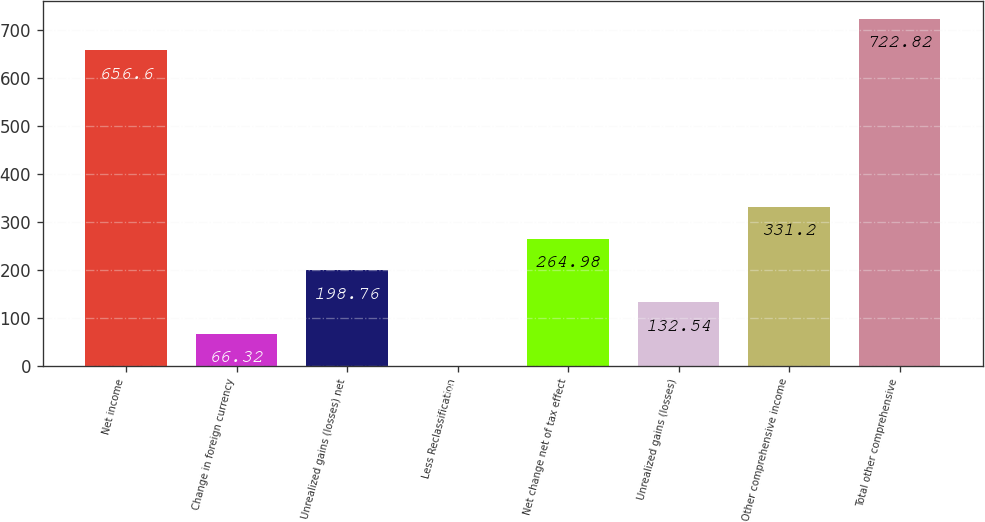<chart> <loc_0><loc_0><loc_500><loc_500><bar_chart><fcel>Net income<fcel>Change in foreign currency<fcel>Unrealized gains (losses) net<fcel>Less Reclassification<fcel>Net change net of tax effect<fcel>Unrealized gains (losses)<fcel>Other comprehensive income<fcel>Total other comprehensive<nl><fcel>656.6<fcel>66.32<fcel>198.76<fcel>0.1<fcel>264.98<fcel>132.54<fcel>331.2<fcel>722.82<nl></chart> 